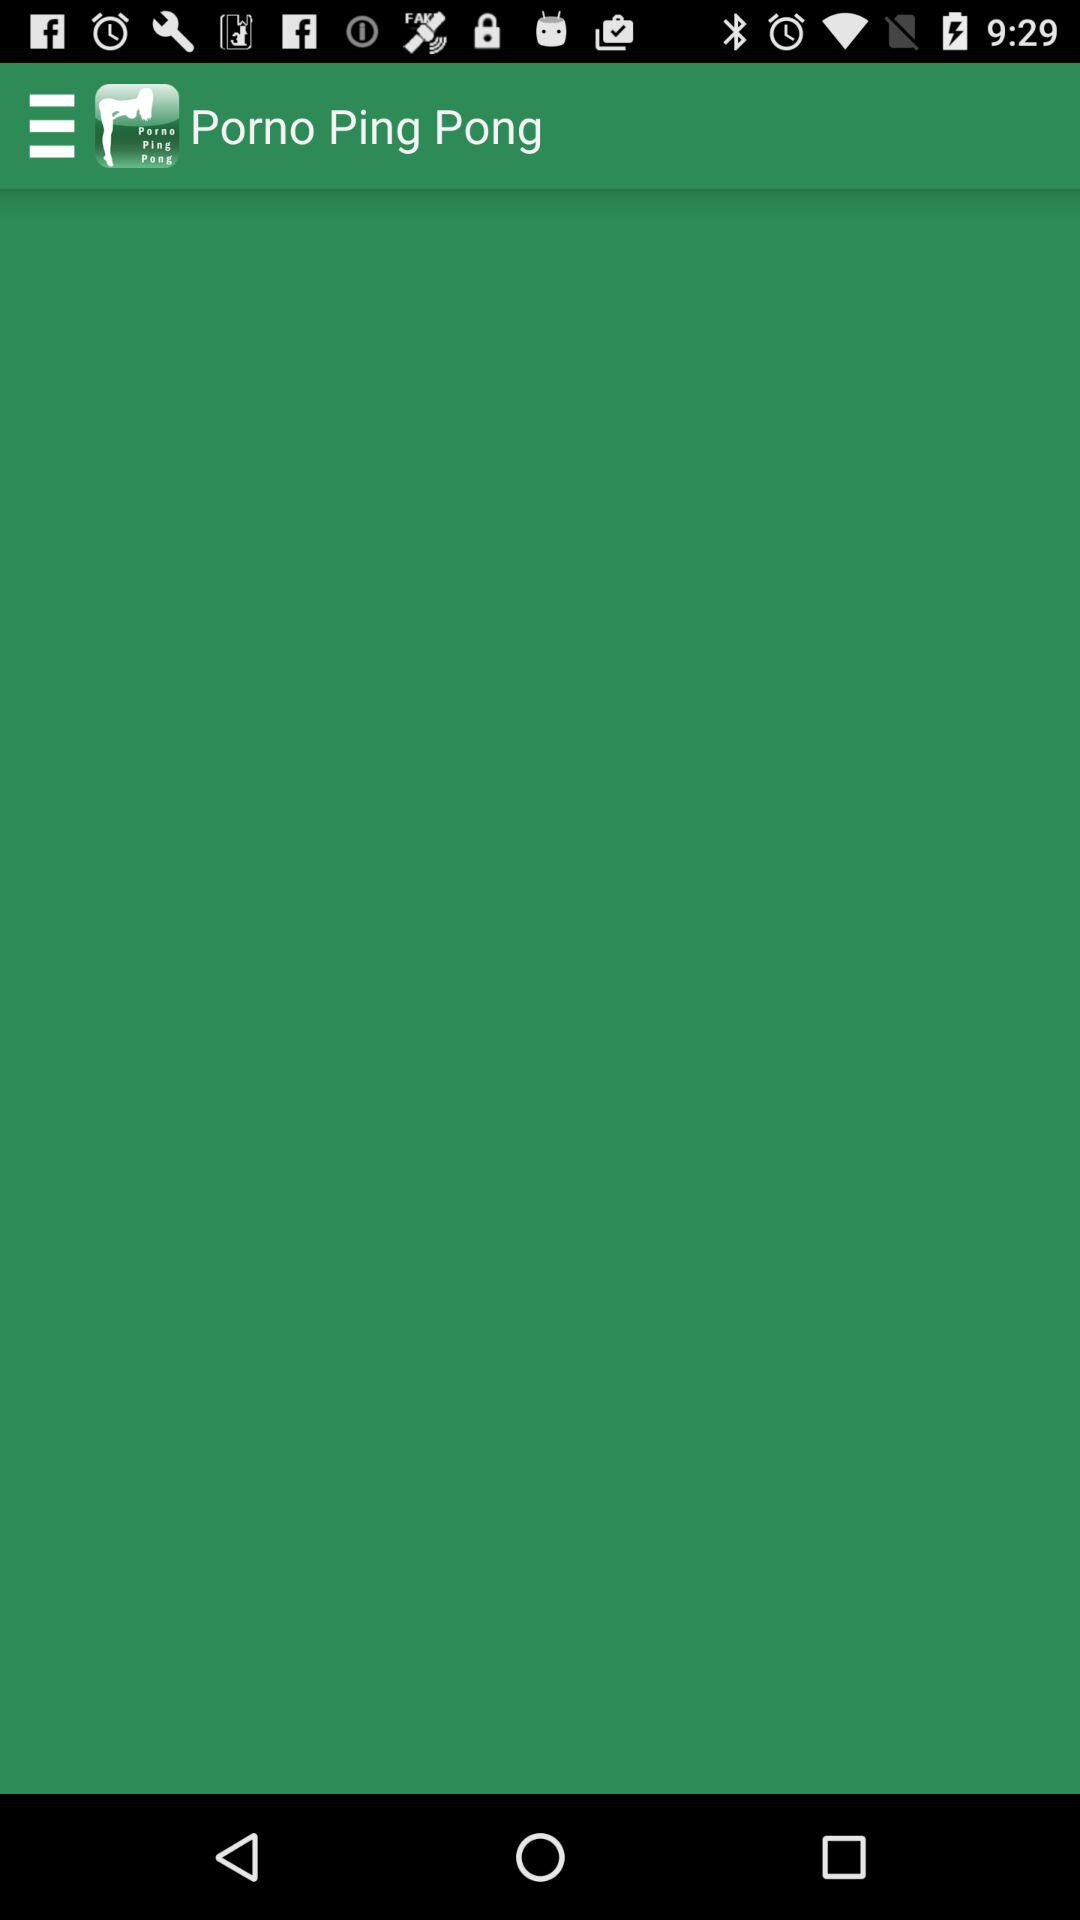Which version of "Porno Ping Pong" is this?
When the provided information is insufficient, respond with <no answer>. <no answer> 